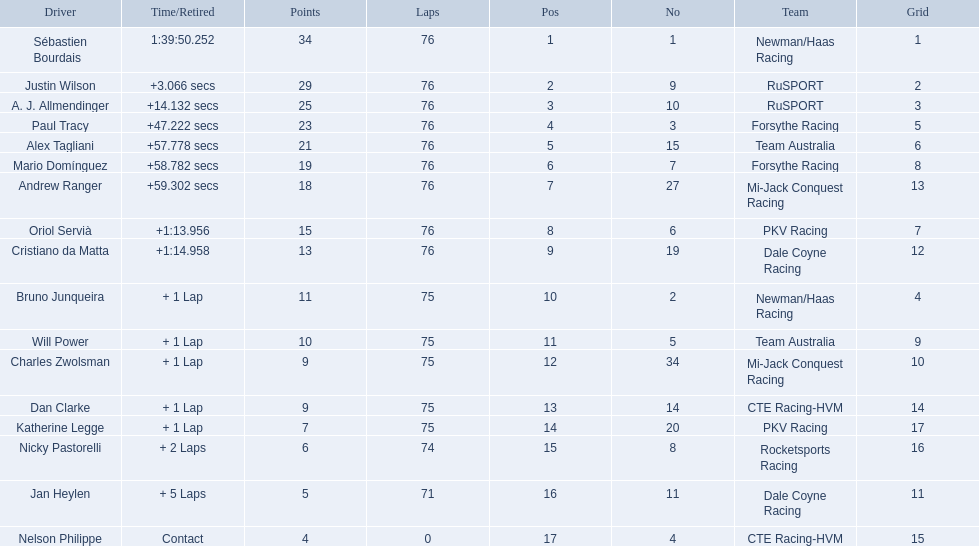How many points did charles zwolsman acquire? 9. Could you parse the entire table? {'header': ['Driver', 'Time/Retired', 'Points', 'Laps', 'Pos', 'No', 'Team', 'Grid'], 'rows': [['Sébastien Bourdais', '1:39:50.252', '34', '76', '1', '1', 'Newman/Haas Racing', '1'], ['Justin Wilson', '+3.066 secs', '29', '76', '2', '9', 'RuSPORT', '2'], ['A. J. Allmendinger', '+14.132 secs', '25', '76', '3', '10', 'RuSPORT', '3'], ['Paul Tracy', '+47.222 secs', '23', '76', '4', '3', 'Forsythe Racing', '5'], ['Alex Tagliani', '+57.778 secs', '21', '76', '5', '15', 'Team Australia', '6'], ['Mario Domínguez', '+58.782 secs', '19', '76', '6', '7', 'Forsythe Racing', '8'], ['Andrew Ranger', '+59.302 secs', '18', '76', '7', '27', 'Mi-Jack Conquest Racing', '13'], ['Oriol Servià', '+1:13.956', '15', '76', '8', '6', 'PKV Racing', '7'], ['Cristiano da Matta', '+1:14.958', '13', '76', '9', '19', 'Dale Coyne Racing', '12'], ['Bruno Junqueira', '+ 1 Lap', '11', '75', '10', '2', 'Newman/Haas Racing', '4'], ['Will Power', '+ 1 Lap', '10', '75', '11', '5', 'Team Australia', '9'], ['Charles Zwolsman', '+ 1 Lap', '9', '75', '12', '34', 'Mi-Jack Conquest Racing', '10'], ['Dan Clarke', '+ 1 Lap', '9', '75', '13', '14', 'CTE Racing-HVM', '14'], ['Katherine Legge', '+ 1 Lap', '7', '75', '14', '20', 'PKV Racing', '17'], ['Nicky Pastorelli', '+ 2 Laps', '6', '74', '15', '8', 'Rocketsports Racing', '16'], ['Jan Heylen', '+ 5 Laps', '5', '71', '16', '11', 'Dale Coyne Racing', '11'], ['Nelson Philippe', 'Contact', '4', '0', '17', '4', 'CTE Racing-HVM', '15']]} Who else got 9 points? Dan Clarke. 